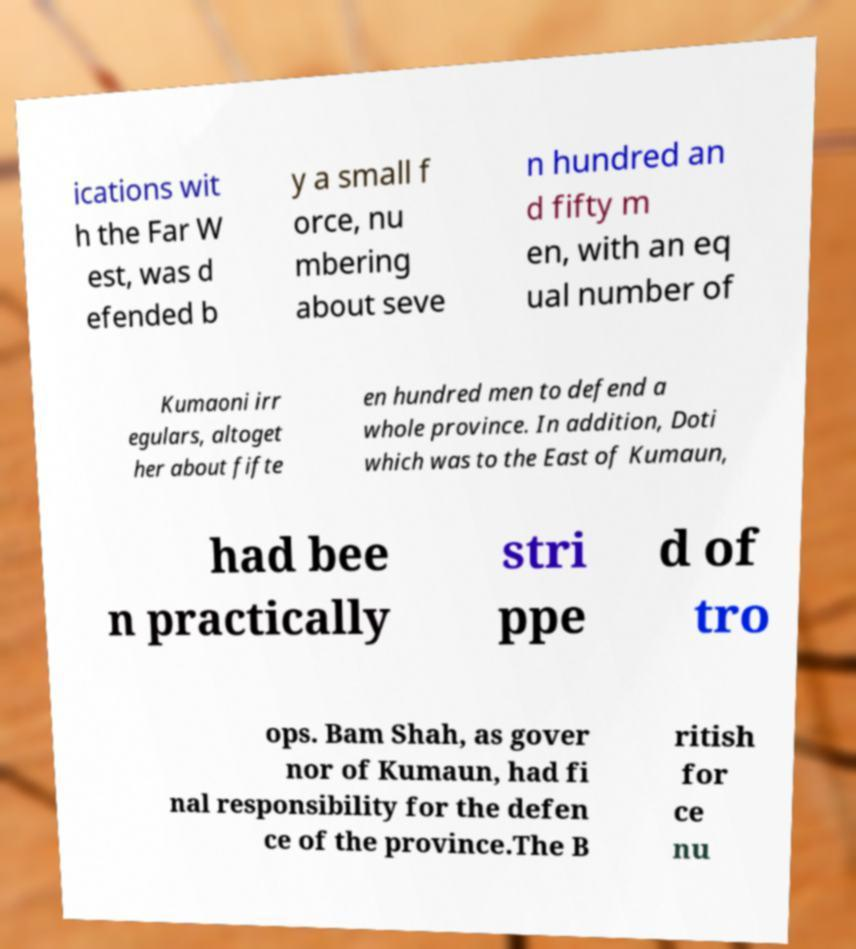Could you assist in decoding the text presented in this image and type it out clearly? ications wit h the Far W est, was d efended b y a small f orce, nu mbering about seve n hundred an d fifty m en, with an eq ual number of Kumaoni irr egulars, altoget her about fifte en hundred men to defend a whole province. In addition, Doti which was to the East of Kumaun, had bee n practically stri ppe d of tro ops. Bam Shah, as gover nor of Kumaun, had fi nal responsibility for the defen ce of the province.The B ritish for ce nu 